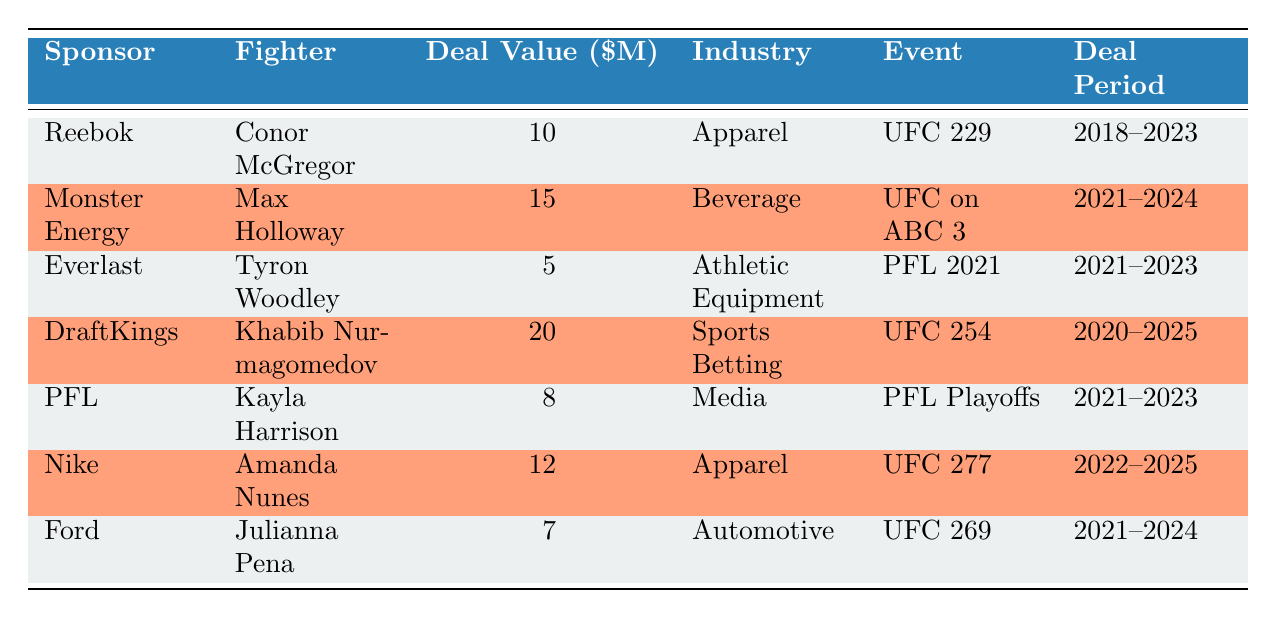What is the deal value for Conor McGregor's sponsorship with Reebok? The table shows that Conor McGregor has a sponsorship deal with Reebok, and its deal value is listed as 10 million.
Answer: 10 million Which fighter has the highest deal value, and what is that amount? By scanning the deal values in the table, DraftKings has the highest deal value of 20 million associated with Khabib Nurmagomedov.
Answer: Khabib Nurmagomedov, 20 million How many sponsorship deals in the table belong to the Apparel industry? There are two entries under the Apparel industry: Reebok with Conor McGregor and Nike with Amanda Nunes. Therefore, the total number of deals in that industry is 2.
Answer: 2 What is the average deal value among all fighters listed in the table? The total deal value is calculated by summing all values (10 + 15 + 5 + 20 + 8 + 12 + 7 = 77 million), and there are 7 fighters, thus the average is 77 million divided by 7, resulting in approximately 11 million.
Answer: 11 million Is there a sponsorship deal with a fighter involved in the Automotive industry? The table indicates that Julianna Pena has a sponsorship deal with Ford, which is categorized under the Automotive industry, thus confirming that such a deal exists.
Answer: Yes Which fighter has a deal that lasts the longest period, and what are the start and end dates? The longest deal is for Khabib Nurmagomedov with DraftKings, which starts on October 1, 2020, and ends on October 1, 2025, resulting in a 5-year period.
Answer: Khabib Nurmagomedov, October 1, 2020 - October 1, 2025 Do any fighters have sponsorship deals that will expire in 2023? Both Reebok (Conor McGregor) and Everlast (Tyron Woodley) have deals that end in 2023, confirming the presence of such fighters in the table.
Answer: Yes What is the total deal value of all sponsorships from the Beverage industry? The only sponsorship in the Beverage industry is from Monster Energy with Max Holloway valued at 15 million. So, the total deal value is 15 million.
Answer: 15 million 